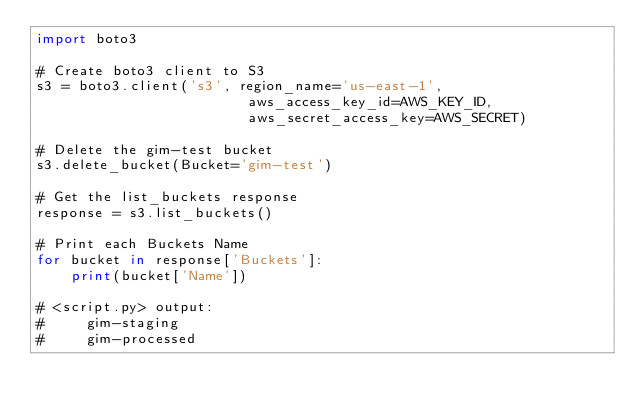Convert code to text. <code><loc_0><loc_0><loc_500><loc_500><_Python_>import boto3

# Create boto3 client to S3
s3 = boto3.client('s3', region_name='us-east-1', 
                         aws_access_key_id=AWS_KEY_ID, 
                         aws_secret_access_key=AWS_SECRET)

# Delete the gim-test bucket
s3.delete_bucket(Bucket='gim-test')

# Get the list_buckets response
response = s3.list_buckets()

# Print each Buckets Name
for bucket in response['Buckets']:
    print(bucket['Name'])

# <script.py> output:
#     gim-staging
#     gim-processed</code> 